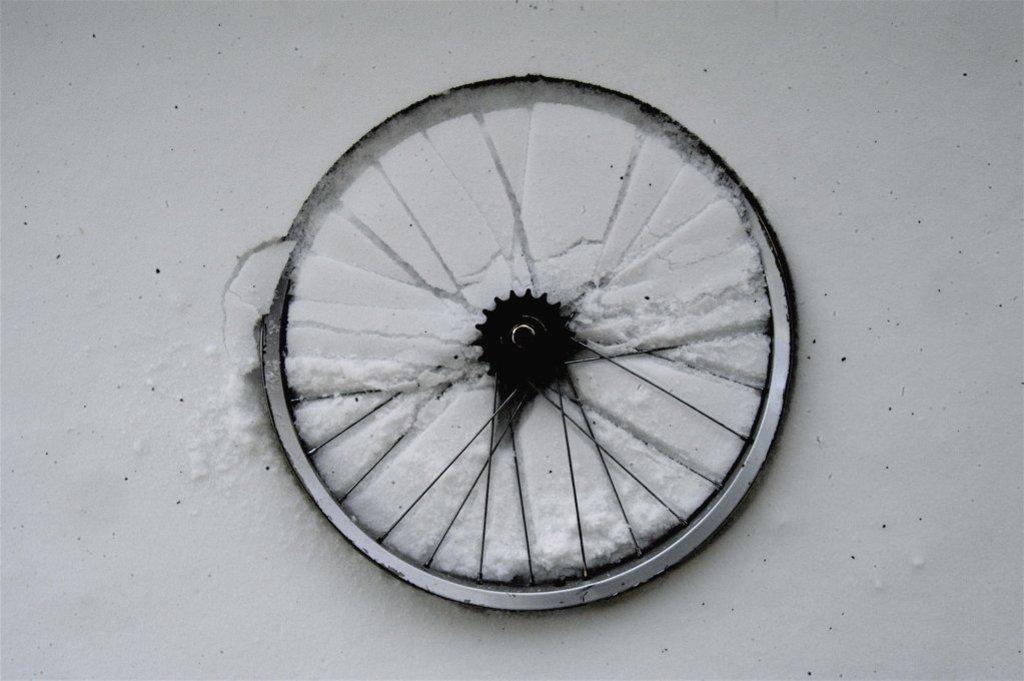How would you summarize this image in a sentence or two? In this image I can see a wheel. The background is white in color. It is looking like some snow on the ground. 